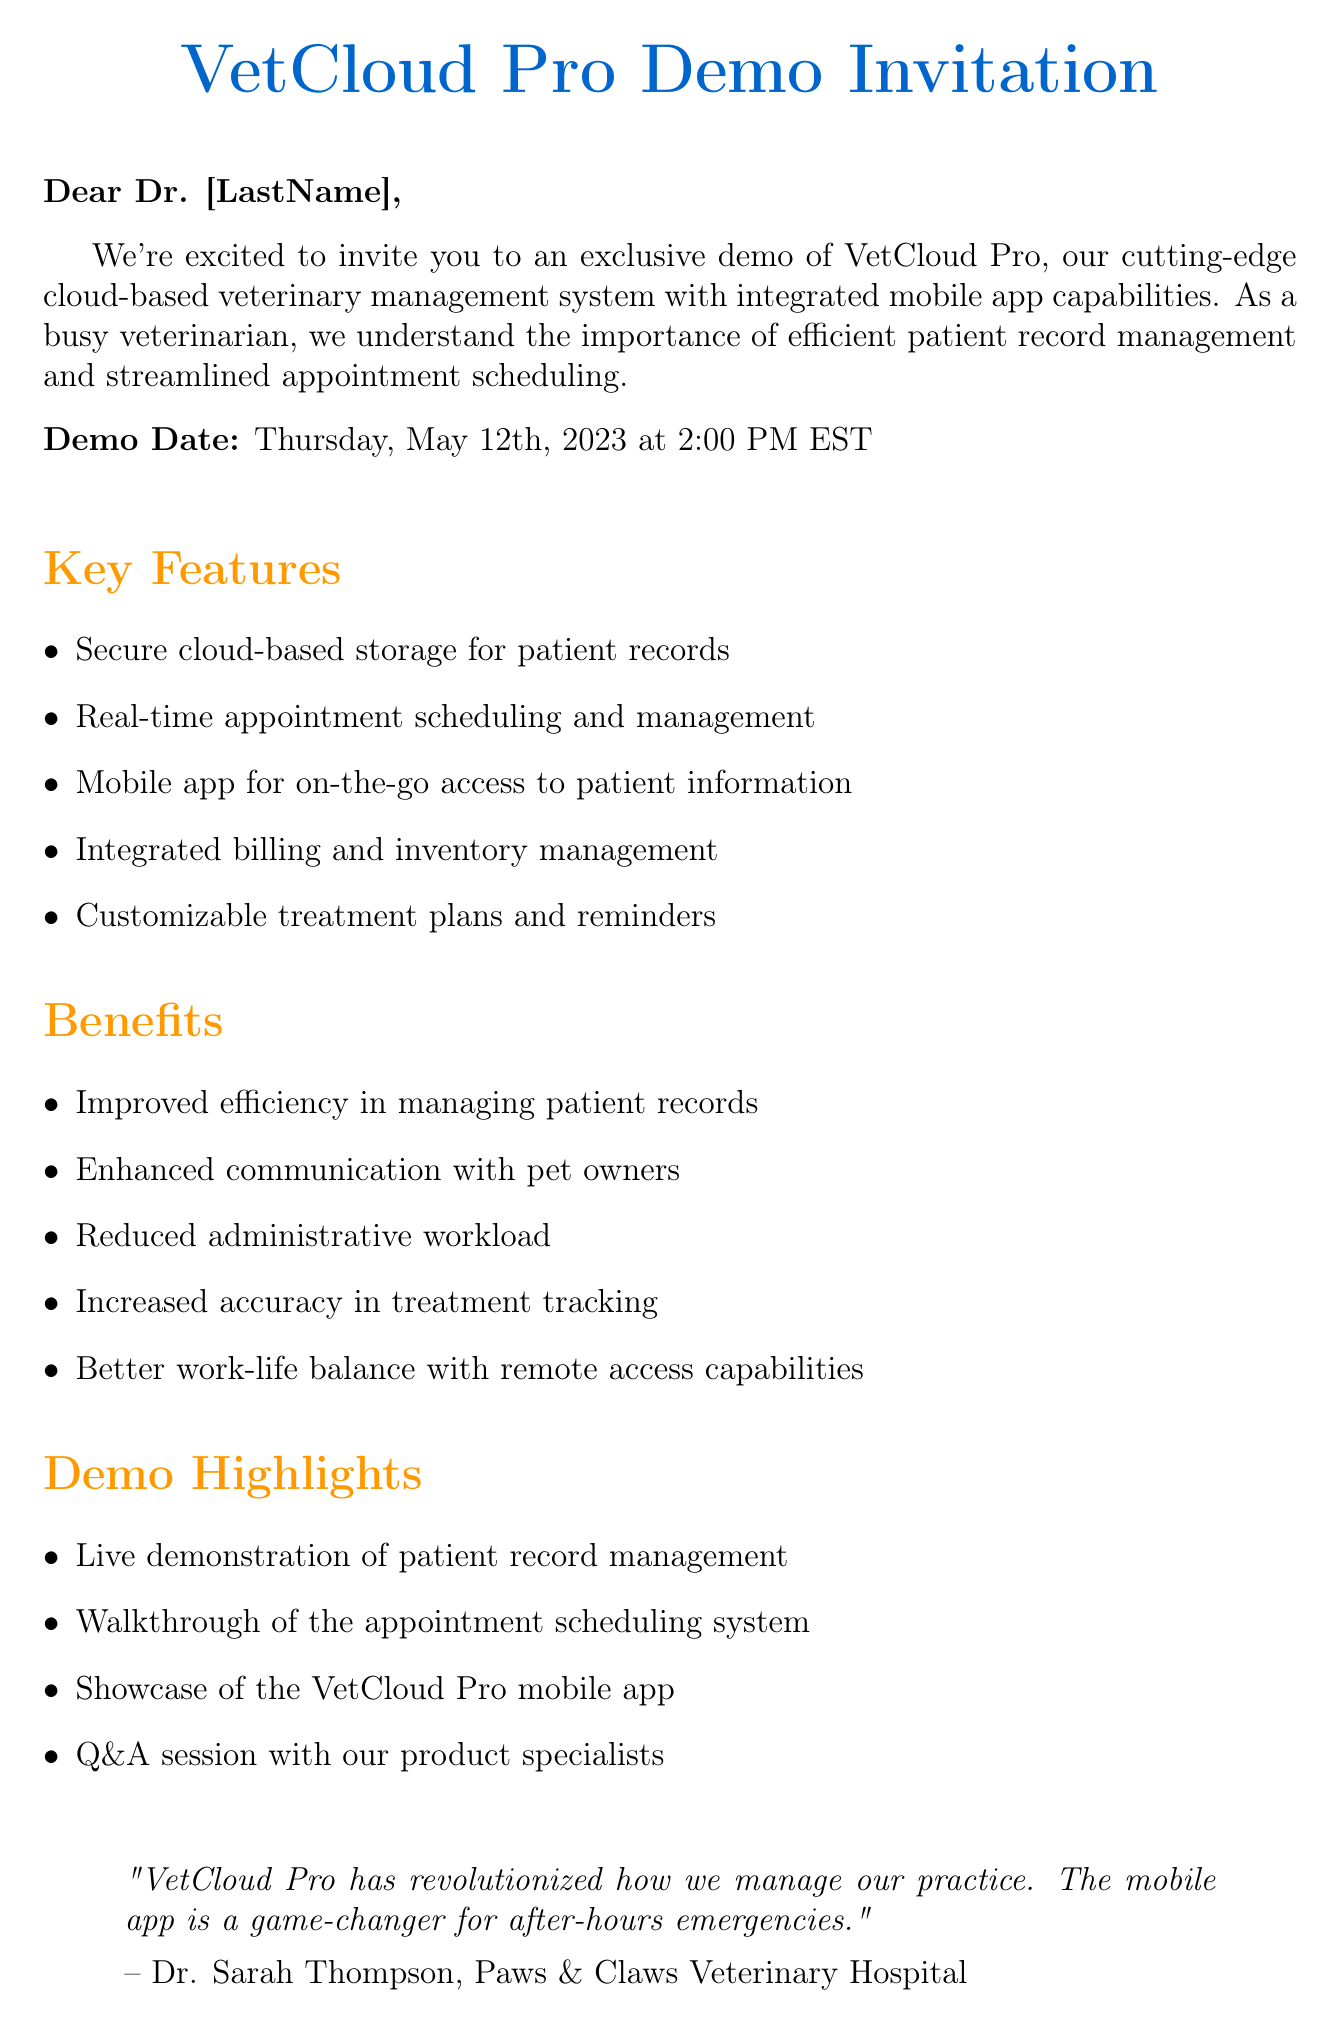What is the demo date? The demo date is explicitly mentioned in the introduction section of the document.
Answer: Thursday, May 12th, 2023 What time is the demo scheduled for? The demo time is stated directly after the demo date.
Answer: 2:00 PM EST Who is the author of the testimonial? The testimonial segment includes information about the person who provided it.
Answer: Dr. Sarah Thompson What is one of the key features of VetCloud Pro? The key features are listed in a bullet point format within the document.
Answer: Secure cloud-based storage for patient records What benefit is related to communication with pet owners? The benefits section includes statements about the advantages of using VetCloud Pro.
Answer: Enhanced communication with pet owners What type of session will be included in the demo? The demo highlights list specific activities that will occur during the demonstration.
Answer: Q&A session with our product specialists Which platform is mentioned in the system requirements? The system requirements detail the compatible operating systems for VetCloud Pro.
Answer: Windows 10 Is customer support available at all times? The document states the support availability in the additional information section.
Answer: 24/7 customer support What should you do to reserve a spot for the demo? The call to action clearly indicates the steps to reserve a demo spot.
Answer: Click the button below or reply to this email 